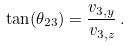Convert formula to latex. <formula><loc_0><loc_0><loc_500><loc_500>\tan ( \theta _ { 2 3 } ) = \frac { v _ { 3 , y } } { v _ { 3 , z } } \, .</formula> 